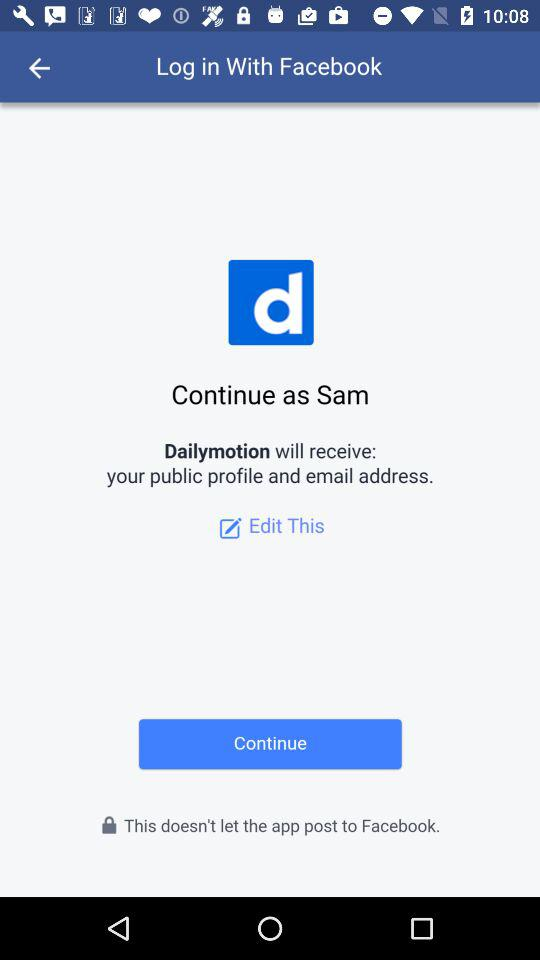What is the name of the user? The name of the user is Sam. 